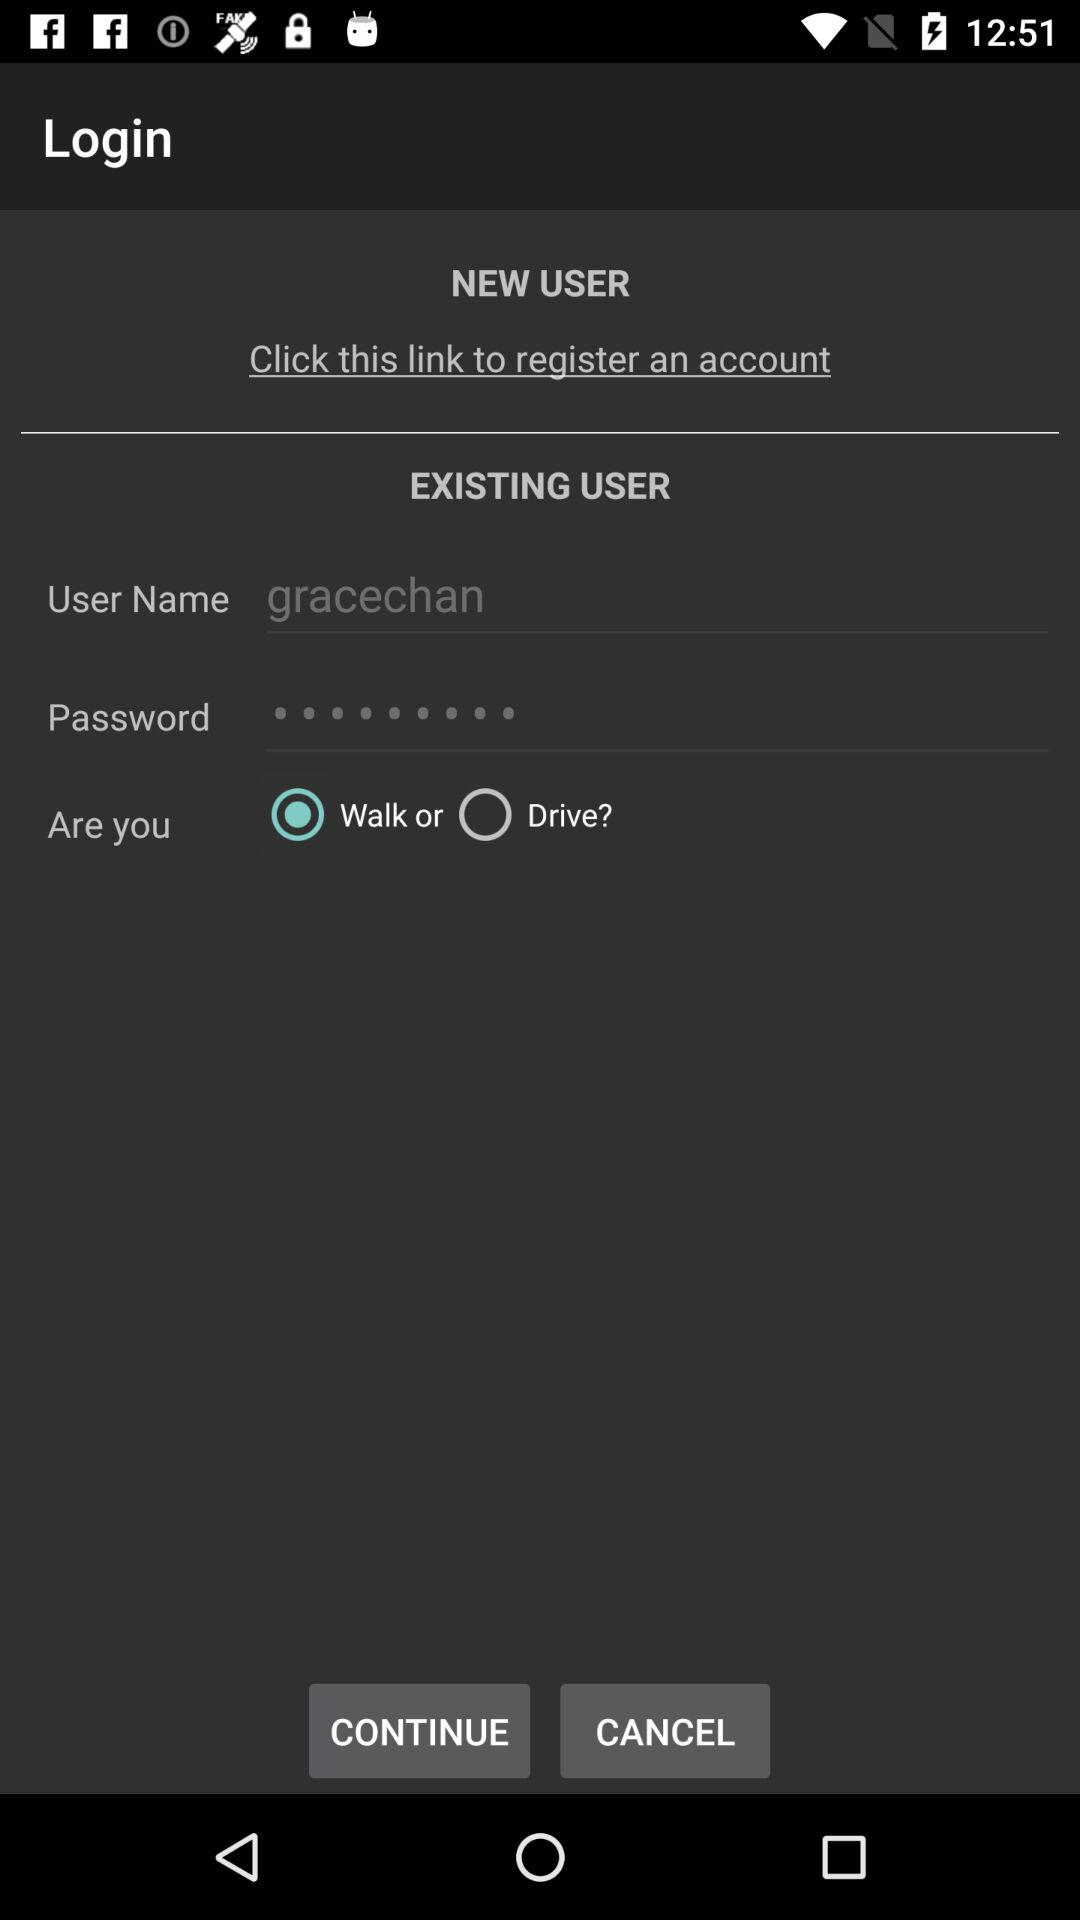What is the user name? The user name is gracechan. 